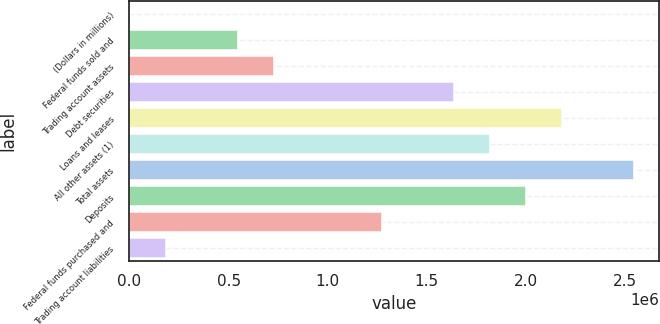Convert chart. <chart><loc_0><loc_0><loc_500><loc_500><bar_chart><fcel>(Dollars in millions)<fcel>Federal funds sold and<fcel>Trading account assets<fcel>Debt securities<fcel>Loans and leases<fcel>All other assets (1)<fcel>Total assets<fcel>Deposits<fcel>Federal funds purchased and<fcel>Trading account liabilities<nl><fcel>2008<fcel>546788<fcel>728382<fcel>1.63635e+06<fcel>2.18113e+06<fcel>1.81794e+06<fcel>2.54432e+06<fcel>1.99954e+06<fcel>1.27316e+06<fcel>183602<nl></chart> 